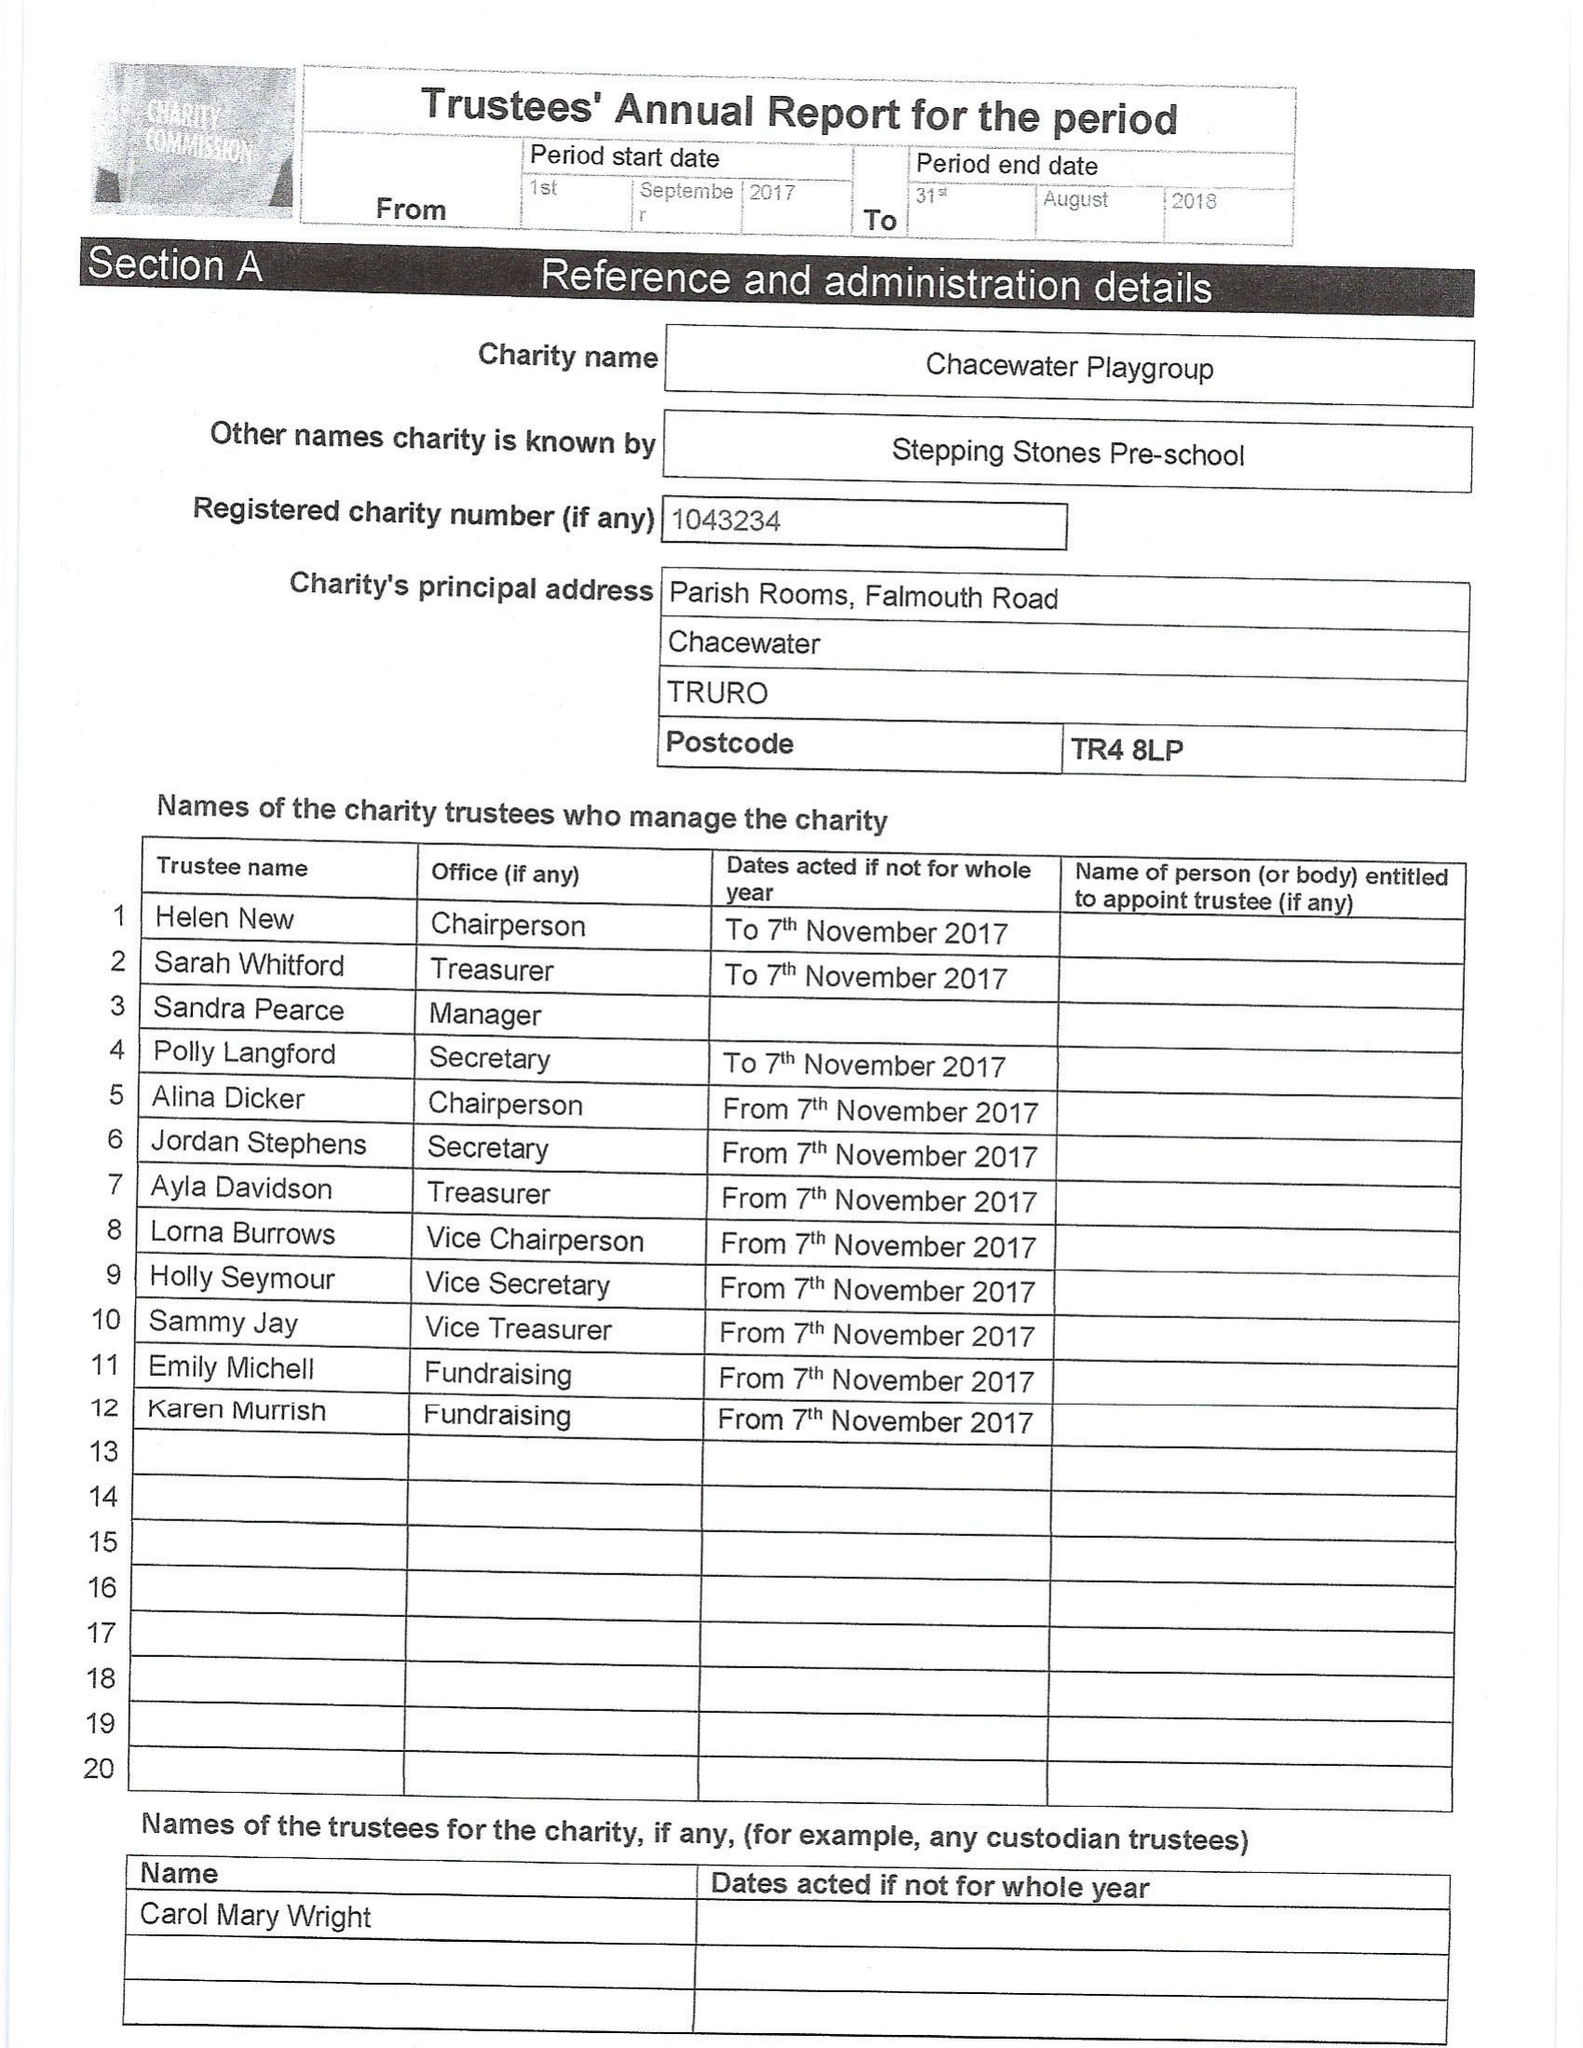What is the value for the charity_name?
Answer the question using a single word or phrase. Chacewater Playgroup 